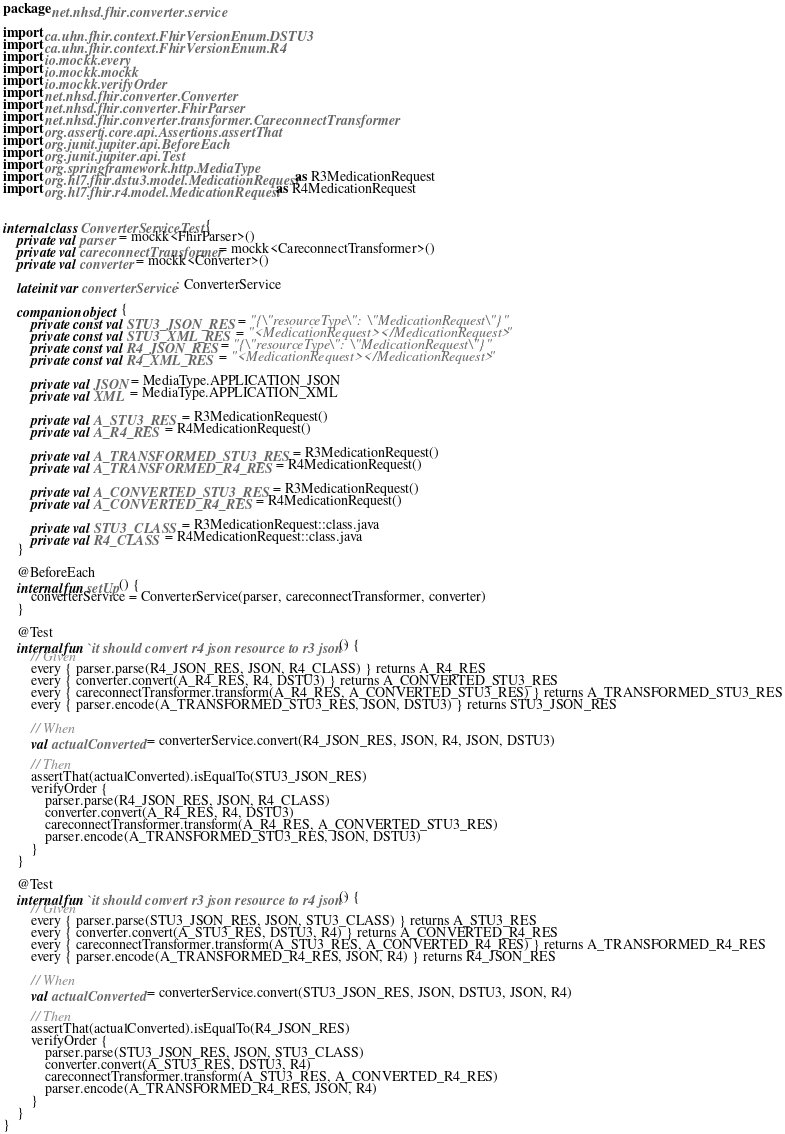Convert code to text. <code><loc_0><loc_0><loc_500><loc_500><_Kotlin_>package net.nhsd.fhir.converter.service

import ca.uhn.fhir.context.FhirVersionEnum.DSTU3
import ca.uhn.fhir.context.FhirVersionEnum.R4
import io.mockk.every
import io.mockk.mockk
import io.mockk.verifyOrder
import net.nhsd.fhir.converter.Converter
import net.nhsd.fhir.converter.FhirParser
import net.nhsd.fhir.converter.transformer.CareconnectTransformer
import org.assertj.core.api.Assertions.assertThat
import org.junit.jupiter.api.BeforeEach
import org.junit.jupiter.api.Test
import org.springframework.http.MediaType
import org.hl7.fhir.dstu3.model.MedicationRequest as R3MedicationRequest
import org.hl7.fhir.r4.model.MedicationRequest as R4MedicationRequest


internal class ConverterServiceTest {
    private val parser = mockk<FhirParser>()
    private val careconnectTransformer = mockk<CareconnectTransformer>()
    private val converter = mockk<Converter>()

    lateinit var converterService: ConverterService

    companion object {
        private const val STU3_JSON_RES = "{\"resourceType\":  \"MedicationRequest\"}"
        private const val STU3_XML_RES = "<MedicationRequest></MedicationRequest>"
        private const val R4_JSON_RES = "{\"resourceType\":  \"MedicationRequest\"}"
        private const val R4_XML_RES = "<MedicationRequest></MedicationRequest>"

        private val JSON = MediaType.APPLICATION_JSON
        private val XML = MediaType.APPLICATION_XML

        private val A_STU3_RES = R3MedicationRequest()
        private val A_R4_RES = R4MedicationRequest()

        private val A_TRANSFORMED_STU3_RES = R3MedicationRequest()
        private val A_TRANSFORMED_R4_RES = R4MedicationRequest()

        private val A_CONVERTED_STU3_RES = R3MedicationRequest()
        private val A_CONVERTED_R4_RES = R4MedicationRequest()

        private val STU3_CLASS = R3MedicationRequest::class.java
        private val R4_CLASS = R4MedicationRequest::class.java
    }

    @BeforeEach
    internal fun setUp() {
        converterService = ConverterService(parser, careconnectTransformer, converter)
    }

    @Test
    internal fun `it should convert r4 json resource to r3 json`() {
        // Given
        every { parser.parse(R4_JSON_RES, JSON, R4_CLASS) } returns A_R4_RES
        every { converter.convert(A_R4_RES, R4, DSTU3) } returns A_CONVERTED_STU3_RES
        every { careconnectTransformer.transform(A_R4_RES, A_CONVERTED_STU3_RES) } returns A_TRANSFORMED_STU3_RES
        every { parser.encode(A_TRANSFORMED_STU3_RES, JSON, DSTU3) } returns STU3_JSON_RES

        // When
        val actualConverted = converterService.convert(R4_JSON_RES, JSON, R4, JSON, DSTU3)

        // Then
        assertThat(actualConverted).isEqualTo(STU3_JSON_RES)
        verifyOrder {
            parser.parse(R4_JSON_RES, JSON, R4_CLASS)
            converter.convert(A_R4_RES, R4, DSTU3)
            careconnectTransformer.transform(A_R4_RES, A_CONVERTED_STU3_RES)
            parser.encode(A_TRANSFORMED_STU3_RES, JSON, DSTU3)
        }
    }

    @Test
    internal fun `it should convert r3 json resource to r4 json`() {
        // Given
        every { parser.parse(STU3_JSON_RES, JSON, STU3_CLASS) } returns A_STU3_RES
        every { converter.convert(A_STU3_RES, DSTU3, R4) } returns A_CONVERTED_R4_RES
        every { careconnectTransformer.transform(A_STU3_RES, A_CONVERTED_R4_RES) } returns A_TRANSFORMED_R4_RES
        every { parser.encode(A_TRANSFORMED_R4_RES, JSON, R4) } returns R4_JSON_RES

        // When
        val actualConverted = converterService.convert(STU3_JSON_RES, JSON, DSTU3, JSON, R4)

        // Then
        assertThat(actualConverted).isEqualTo(R4_JSON_RES)
        verifyOrder {
            parser.parse(STU3_JSON_RES, JSON, STU3_CLASS)
            converter.convert(A_STU3_RES, DSTU3, R4)
            careconnectTransformer.transform(A_STU3_RES, A_CONVERTED_R4_RES)
            parser.encode(A_TRANSFORMED_R4_RES, JSON, R4)
        }
    }
}
</code> 